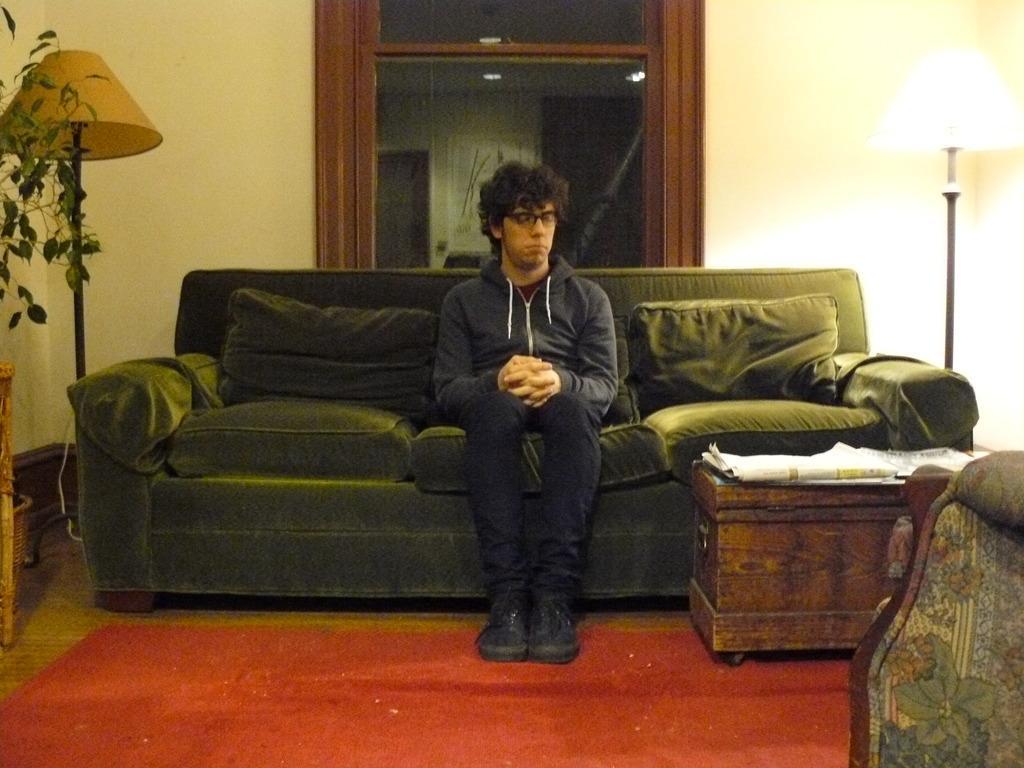Can you describe this image briefly? This man is sitting on a couch with pillows. Backside of this man there is a window with glass. This is a lantern lamp with pole. On this table there are papers. This is a plant. A floor with red carpet. 